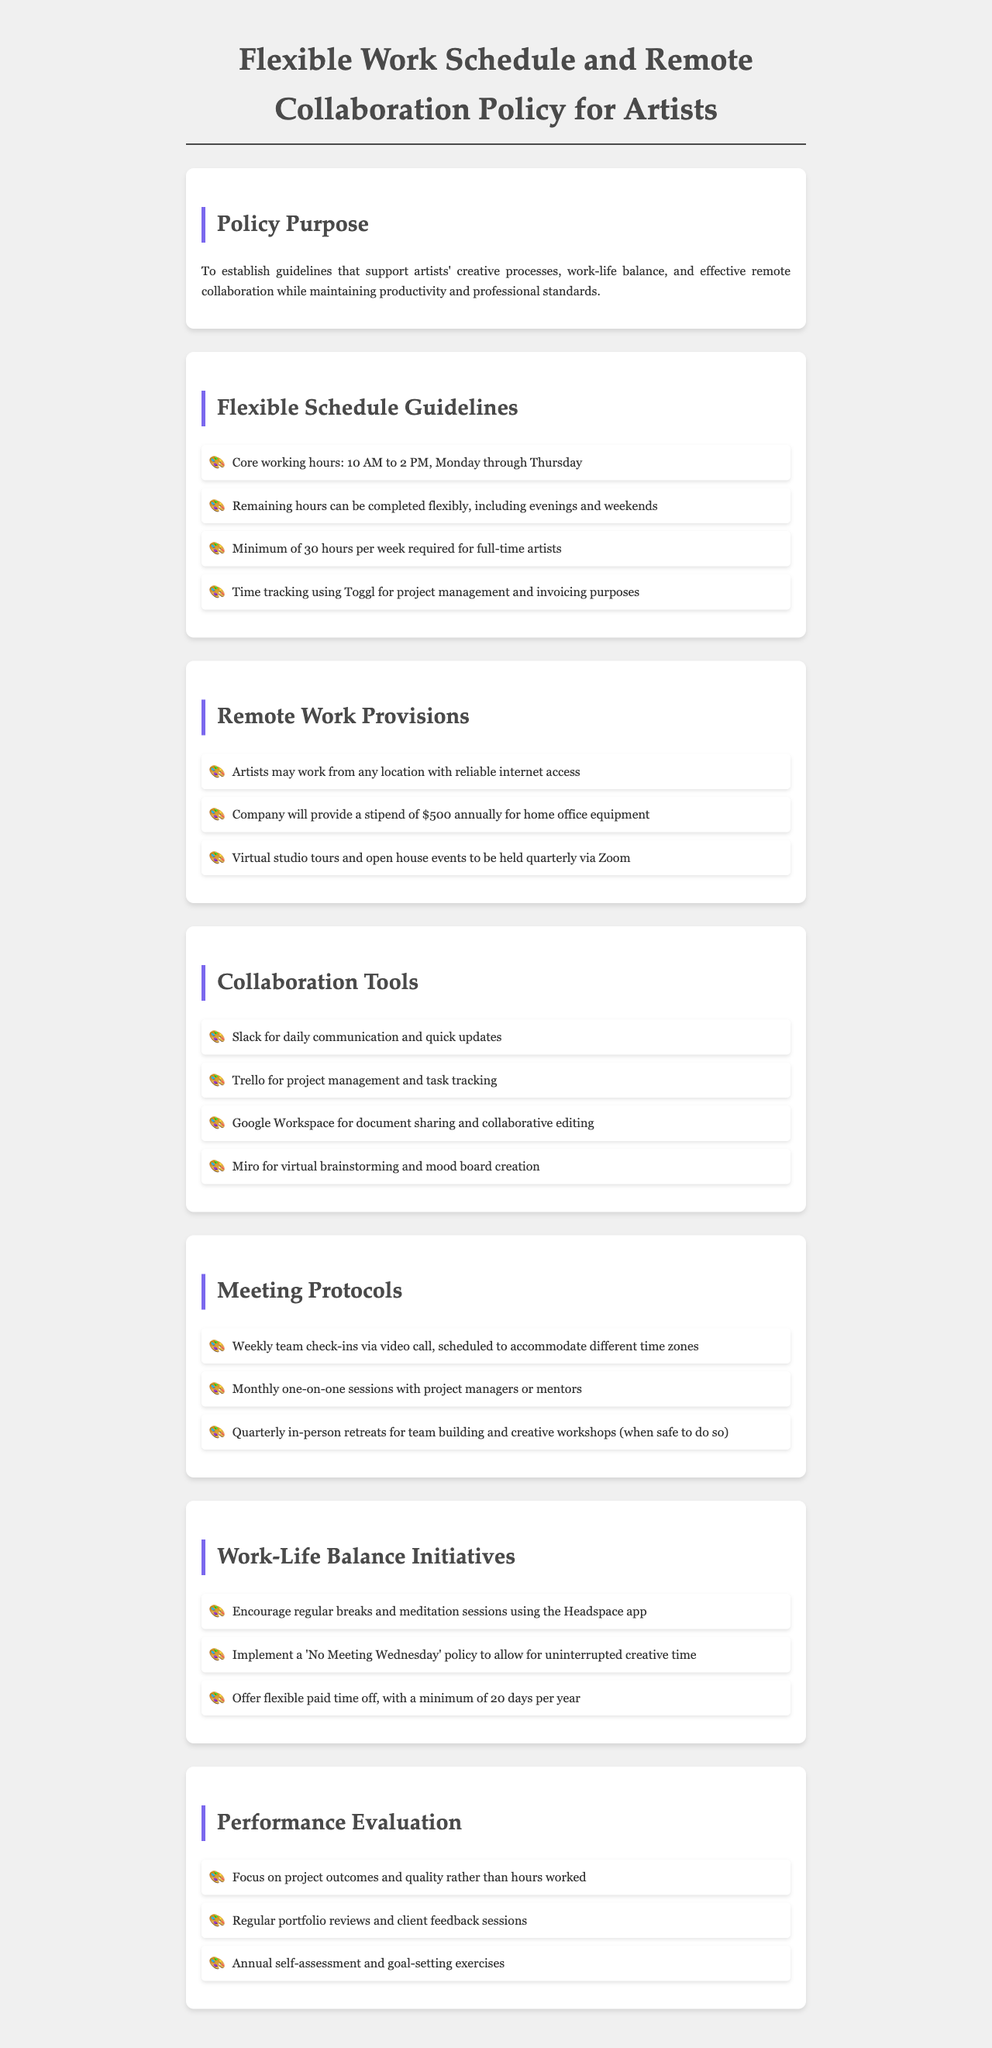What are the core working hours? The core working hours are specified in the Flexible Schedule Guidelines section of the document.
Answer: 10 AM to 2 PM How much is the annual stipend for home office equipment? The stipend amount is listed under the Remote Work Provisions section of the document.
Answer: $500 What is the minimum paid time off per year? The minimum paid time off is mentioned in the Work-Life Balance Initiatives section.
Answer: 20 days Which app is recommended for meditation sessions? This information can be found in the Work-Life Balance Initiatives section regarding breaks and mindfulness.
Answer: Headspace How often are team check-ins scheduled? The frequency of team check-ins is mentioned in the Meeting Protocols section of the document.
Answer: Weekly What is the purpose of the policy? The purpose statement is detailed in the Policy Purpose section at the beginning of the document.
Answer: Support artists' creative processes Which tool is used for project management? The document lists collaboration tools under the Collaboration Tools section.
Answer: Trello What initiative allows for uninterrupted creative time? This initiative is described in the Work-Life Balance Initiatives section as part of work-life balance practices.
Answer: No Meeting Wednesday How frequently are virtual studio tours held? This frequency is stated in the Remote Work Provisions section of the document.
Answer: Quarterly 